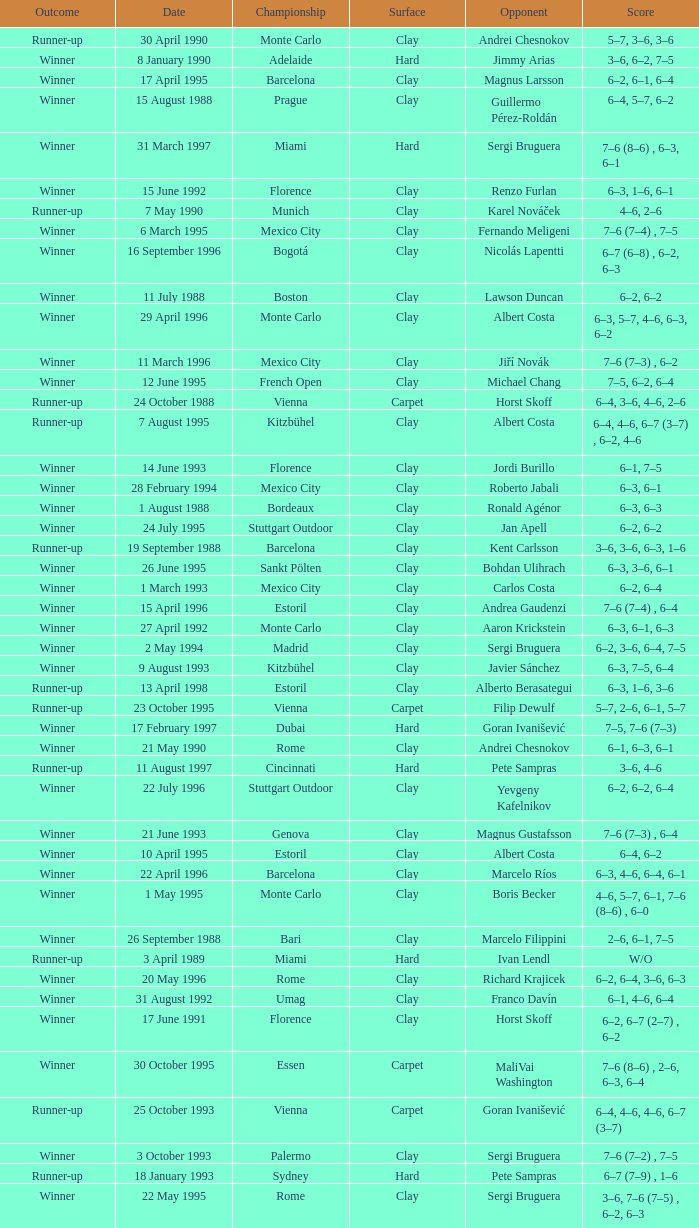Who is the opponent on 18 january 1993? Pete Sampras. 